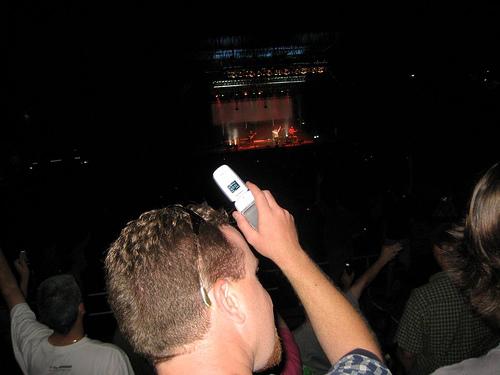What race is the person?
Quick response, please. White. What color is his phone?
Give a very brief answer. White. Are they at a concert?
Keep it brief. Yes. 